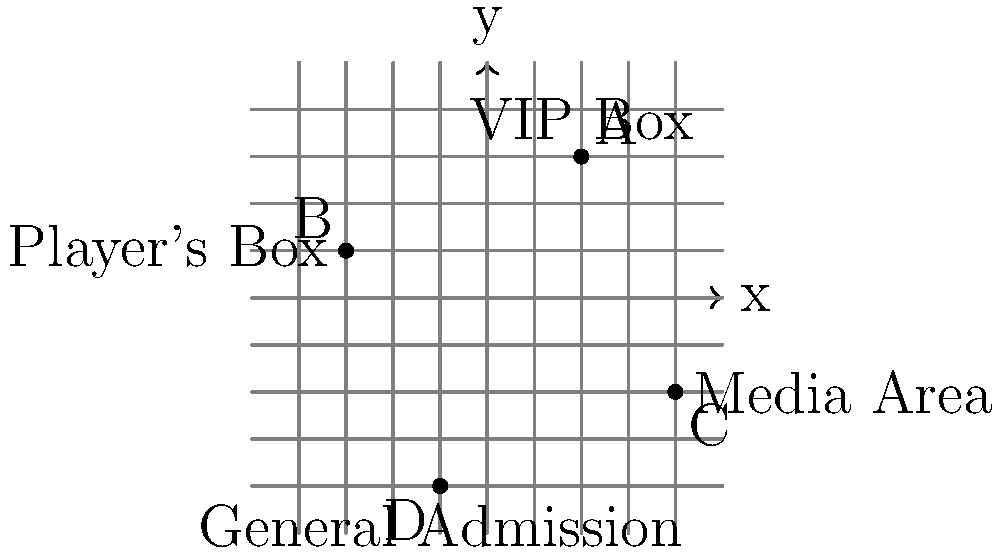In the coordinate grid representing a tennis stadium seating layout, which area is located at the coordinates $(4, -2)$? To answer this question, we need to follow these steps:

1. Understand the coordinate system: The horizontal axis represents the x-coordinate, and the vertical axis represents the y-coordinate.

2. Locate the point (4, -2):
   - Move 4 units to the right from the origin (0, 0) along the x-axis.
   - Then move 2 units down along the y-axis.

3. Identify the labeled area at this point:
   - At the coordinates (4, -2), we can see a point labeled "C".
   - Next to this point, we can see the label "Media Area".

Therefore, the area located at the coordinates (4, -2) is the Media Area.
Answer: Media Area 